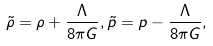Convert formula to latex. <formula><loc_0><loc_0><loc_500><loc_500>\tilde { \rho } = \rho + \frac { \Lambda } { 8 \pi G } , \tilde { p } = p - \frac { \Lambda } { 8 \pi G } ,</formula> 